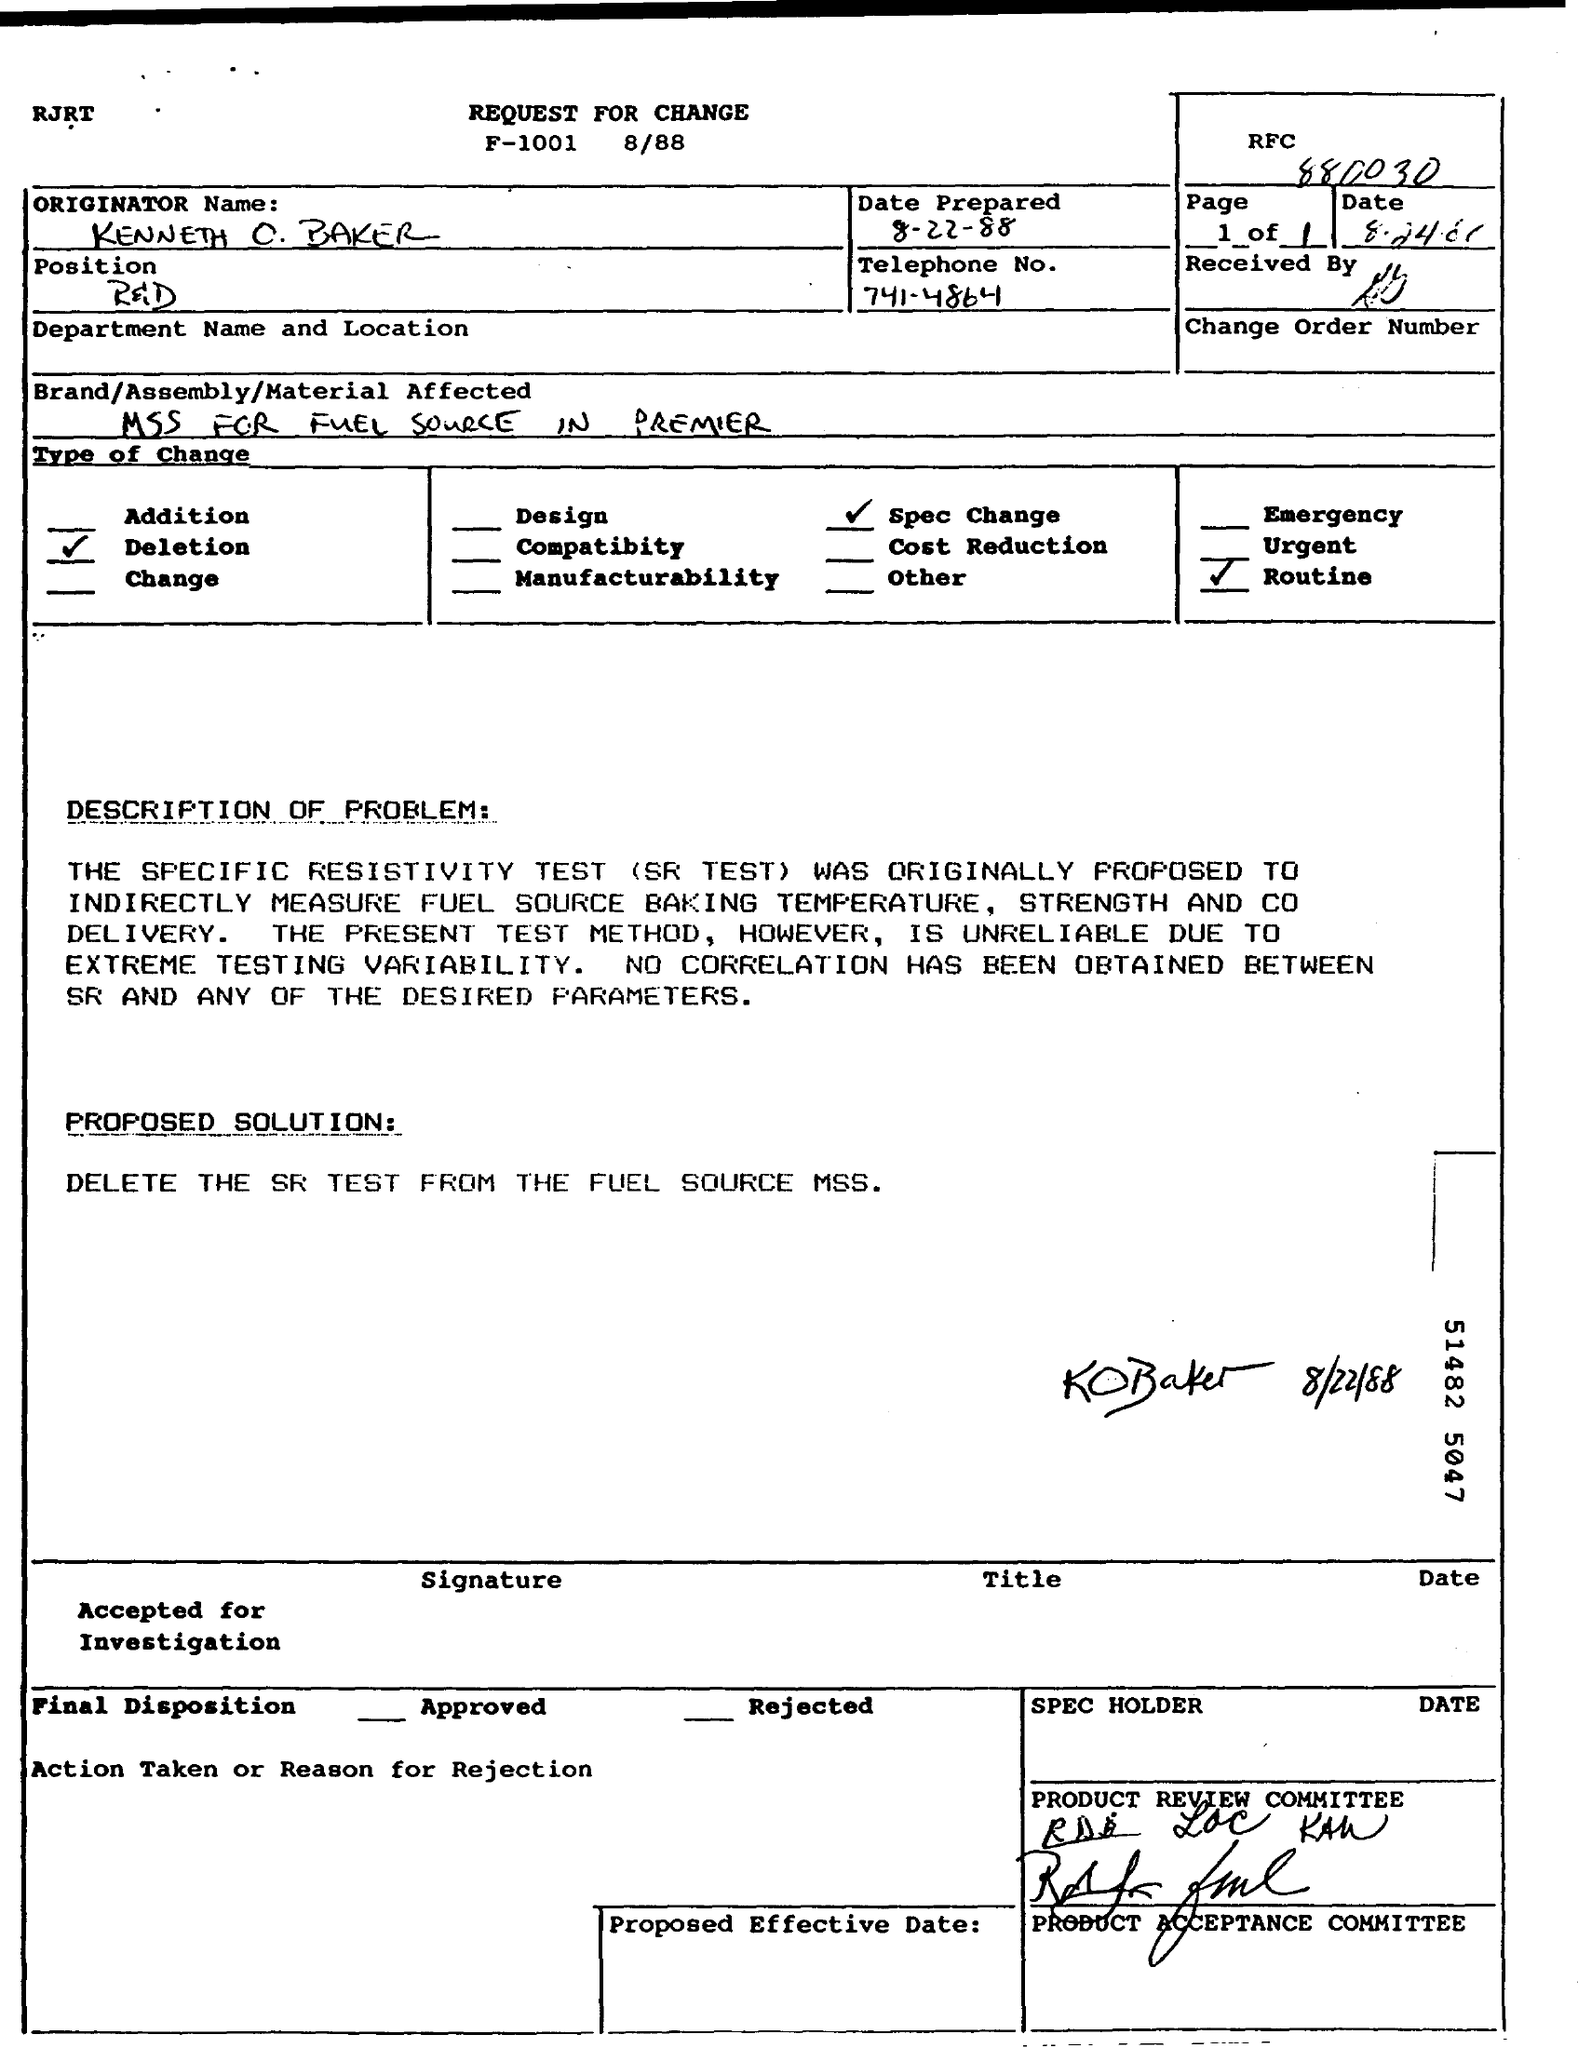What is the Date prepared as per the document? The document's 'Date Prepared' is listed as August 22, 1988. 